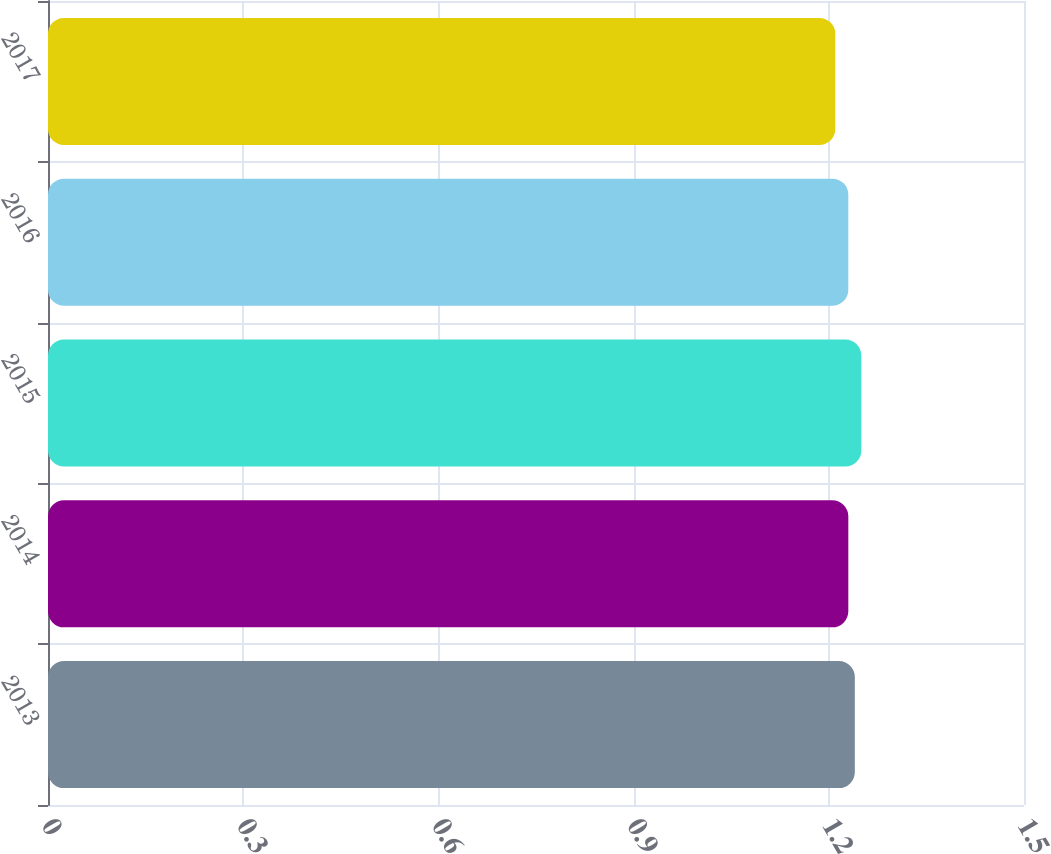<chart> <loc_0><loc_0><loc_500><loc_500><bar_chart><fcel>2013<fcel>2014<fcel>2015<fcel>2016<fcel>2017<nl><fcel>1.24<fcel>1.23<fcel>1.25<fcel>1.23<fcel>1.21<nl></chart> 